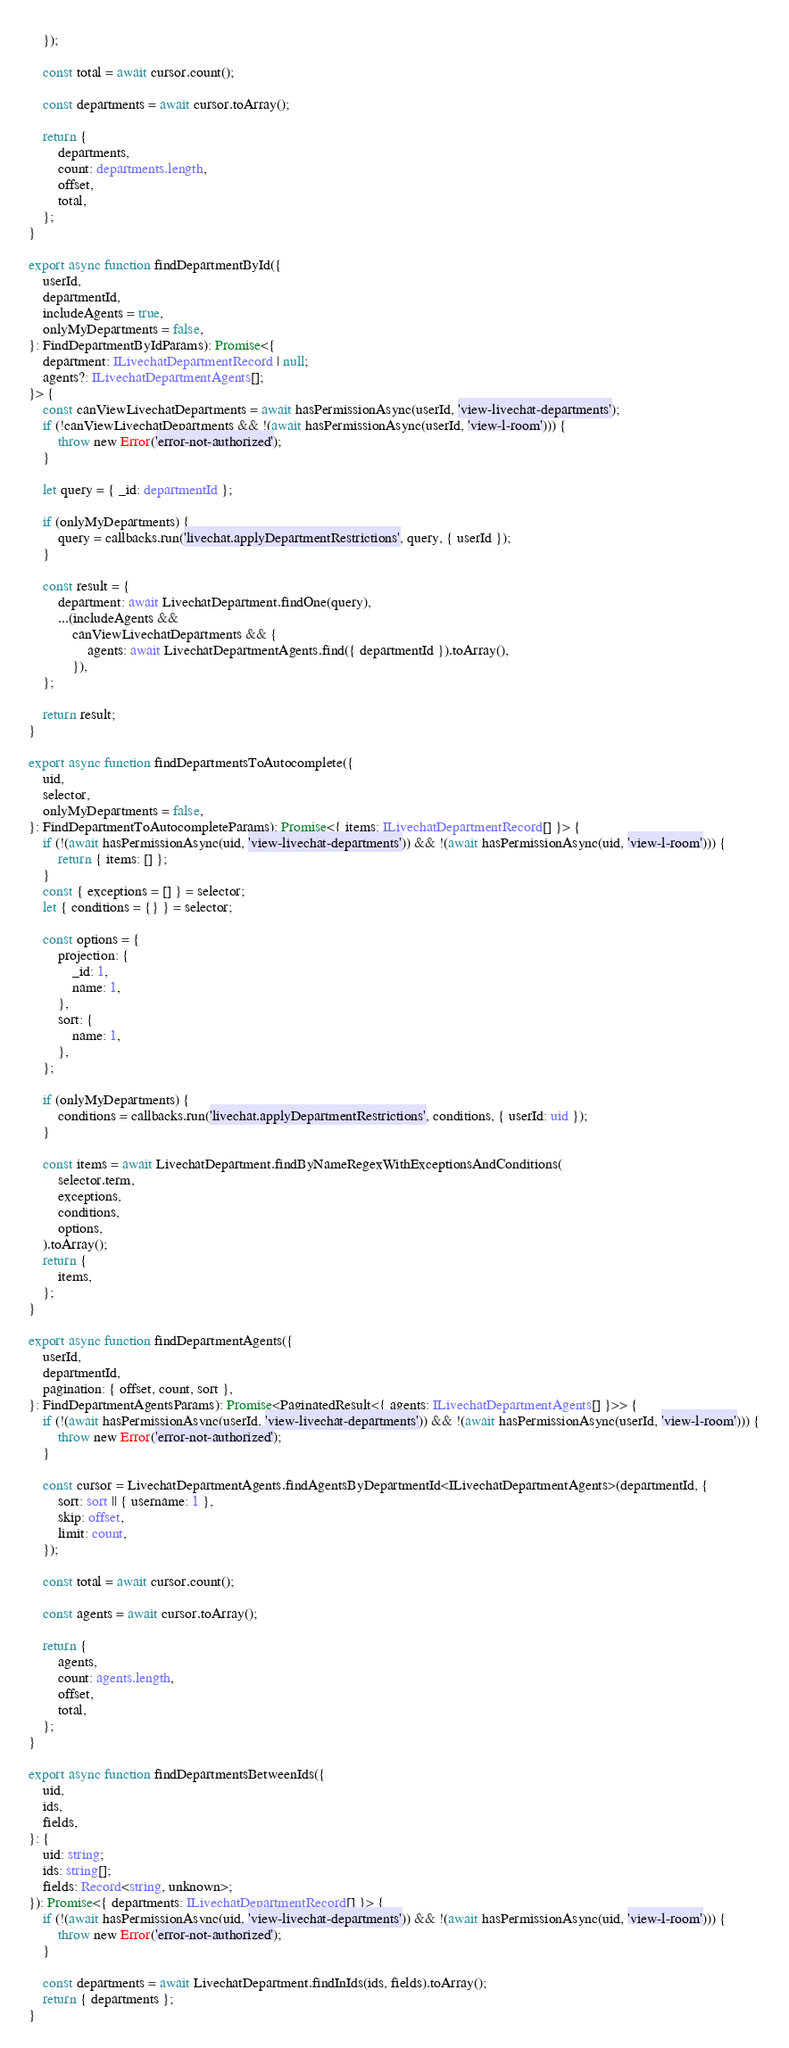Convert code to text. <code><loc_0><loc_0><loc_500><loc_500><_TypeScript_>	});

	const total = await cursor.count();

	const departments = await cursor.toArray();

	return {
		departments,
		count: departments.length,
		offset,
		total,
	};
}

export async function findDepartmentById({
	userId,
	departmentId,
	includeAgents = true,
	onlyMyDepartments = false,
}: FindDepartmentByIdParams): Promise<{
	department: ILivechatDepartmentRecord | null;
	agents?: ILivechatDepartmentAgents[];
}> {
	const canViewLivechatDepartments = await hasPermissionAsync(userId, 'view-livechat-departments');
	if (!canViewLivechatDepartments && !(await hasPermissionAsync(userId, 'view-l-room'))) {
		throw new Error('error-not-authorized');
	}

	let query = { _id: departmentId };

	if (onlyMyDepartments) {
		query = callbacks.run('livechat.applyDepartmentRestrictions', query, { userId });
	}

	const result = {
		department: await LivechatDepartment.findOne(query),
		...(includeAgents &&
			canViewLivechatDepartments && {
				agents: await LivechatDepartmentAgents.find({ departmentId }).toArray(),
			}),
	};

	return result;
}

export async function findDepartmentsToAutocomplete({
	uid,
	selector,
	onlyMyDepartments = false,
}: FindDepartmentToAutocompleteParams): Promise<{ items: ILivechatDepartmentRecord[] }> {
	if (!(await hasPermissionAsync(uid, 'view-livechat-departments')) && !(await hasPermissionAsync(uid, 'view-l-room'))) {
		return { items: [] };
	}
	const { exceptions = [] } = selector;
	let { conditions = {} } = selector;

	const options = {
		projection: {
			_id: 1,
			name: 1,
		},
		sort: {
			name: 1,
		},
	};

	if (onlyMyDepartments) {
		conditions = callbacks.run('livechat.applyDepartmentRestrictions', conditions, { userId: uid });
	}

	const items = await LivechatDepartment.findByNameRegexWithExceptionsAndConditions(
		selector.term,
		exceptions,
		conditions,
		options,
	).toArray();
	return {
		items,
	};
}

export async function findDepartmentAgents({
	userId,
	departmentId,
	pagination: { offset, count, sort },
}: FindDepartmentAgentsParams): Promise<PaginatedResult<{ agents: ILivechatDepartmentAgents[] }>> {
	if (!(await hasPermissionAsync(userId, 'view-livechat-departments')) && !(await hasPermissionAsync(userId, 'view-l-room'))) {
		throw new Error('error-not-authorized');
	}

	const cursor = LivechatDepartmentAgents.findAgentsByDepartmentId<ILivechatDepartmentAgents>(departmentId, {
		sort: sort || { username: 1 },
		skip: offset,
		limit: count,
	});

	const total = await cursor.count();

	const agents = await cursor.toArray();

	return {
		agents,
		count: agents.length,
		offset,
		total,
	};
}

export async function findDepartmentsBetweenIds({
	uid,
	ids,
	fields,
}: {
	uid: string;
	ids: string[];
	fields: Record<string, unknown>;
}): Promise<{ departments: ILivechatDepartmentRecord[] }> {
	if (!(await hasPermissionAsync(uid, 'view-livechat-departments')) && !(await hasPermissionAsync(uid, 'view-l-room'))) {
		throw new Error('error-not-authorized');
	}

	const departments = await LivechatDepartment.findInIds(ids, fields).toArray();
	return { departments };
}
</code> 